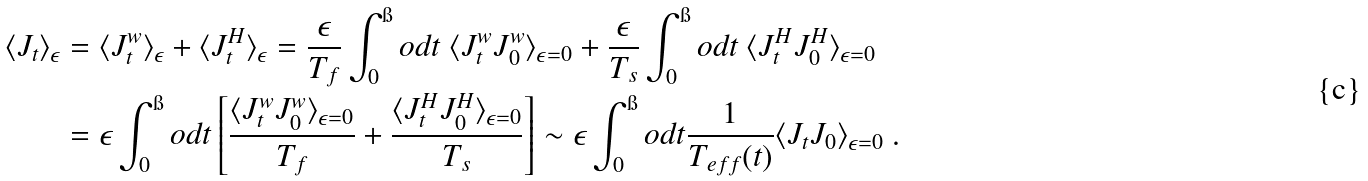<formula> <loc_0><loc_0><loc_500><loc_500>\langle J _ { t } \rangle _ { \epsilon } & = \langle J ^ { w } _ { t } \rangle _ { \epsilon } + \langle J ^ { H } _ { t } \rangle _ { \epsilon } = \frac { \epsilon } { T _ { f } } \int _ { 0 } ^ { \i } o d t \ \langle J ^ { w } _ { t } J ^ { w } _ { 0 } \rangle _ { \epsilon = 0 } + \frac { \epsilon } { T _ { s } } \int _ { 0 } ^ { \i } o d t \ \langle J ^ { H } _ { t } J ^ { H } _ { 0 } \rangle _ { \epsilon = 0 } \\ & = \epsilon \int _ { 0 } ^ { \i } o d t \left [ \frac { \langle J ^ { w } _ { t } J ^ { w } _ { 0 } \rangle _ { \epsilon = 0 } } { T _ { f } } + \frac { \langle J ^ { H } _ { t } J ^ { H } _ { 0 } \rangle _ { \epsilon = 0 } } { T _ { s } } \right ] \sim \epsilon \int _ { 0 } ^ { \i } o d t \frac { 1 } { T _ { e f f } ( t ) } \langle J _ { t } J _ { 0 } \rangle _ { \epsilon = 0 } \ .</formula> 